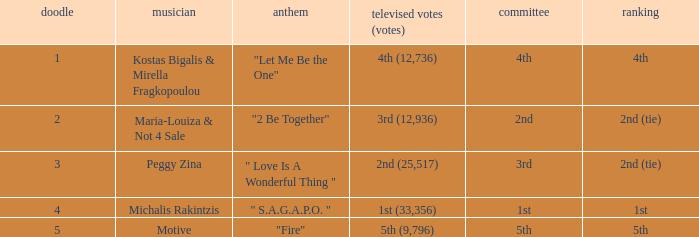What song was 2nd (25,517) in televoting (votes)? " Love Is A Wonderful Thing ". 